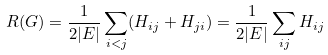<formula> <loc_0><loc_0><loc_500><loc_500>R ( G ) = \frac { 1 } { 2 | E | } \sum _ { i < j } ( H _ { i j } + H _ { j i } ) = \frac { 1 } { 2 | E | } \sum _ { i j } H _ { i j }</formula> 